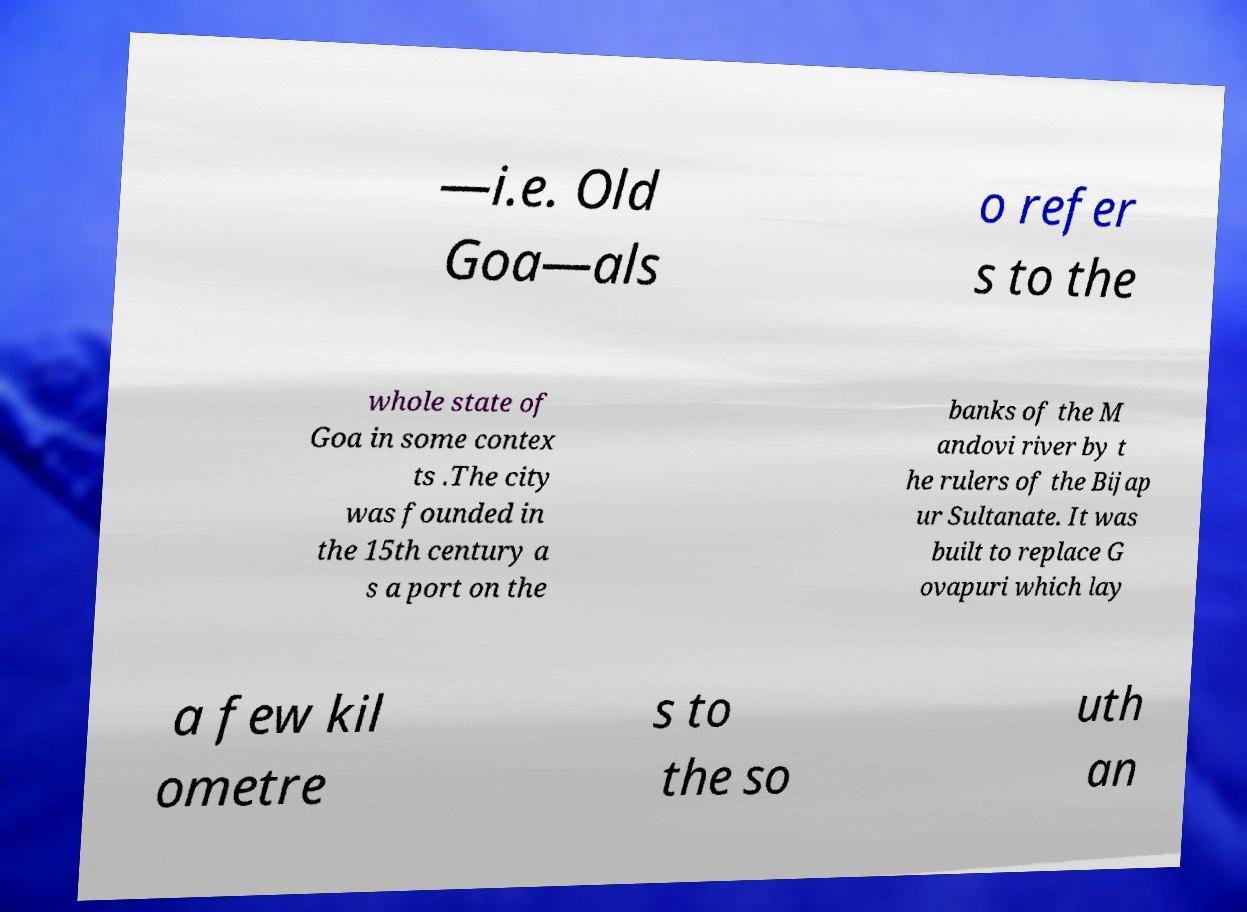I need the written content from this picture converted into text. Can you do that? —i.e. Old Goa—als o refer s to the whole state of Goa in some contex ts .The city was founded in the 15th century a s a port on the banks of the M andovi river by t he rulers of the Bijap ur Sultanate. It was built to replace G ovapuri which lay a few kil ometre s to the so uth an 